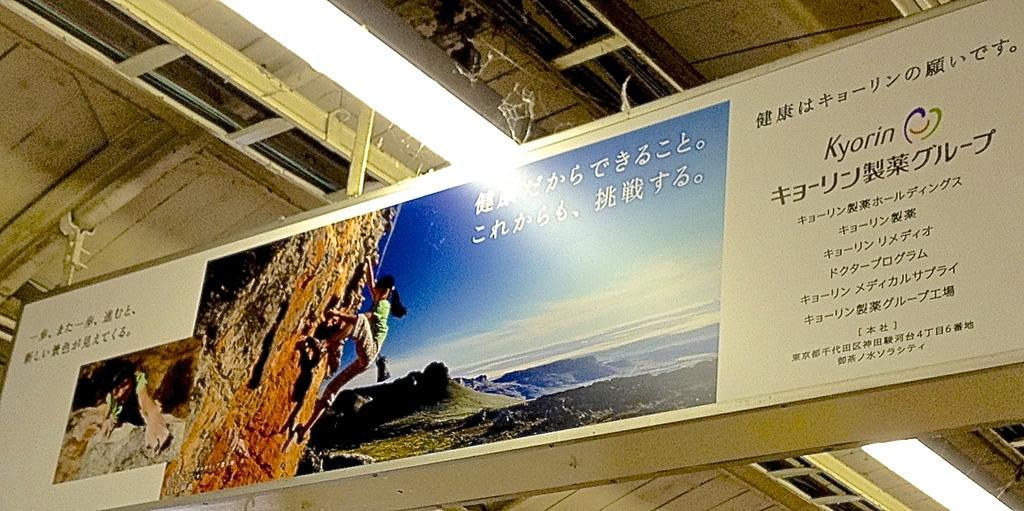Provide a one-sentence caption for the provided image. A sign for mountain climbers in Japanese by the company Kyorin. 